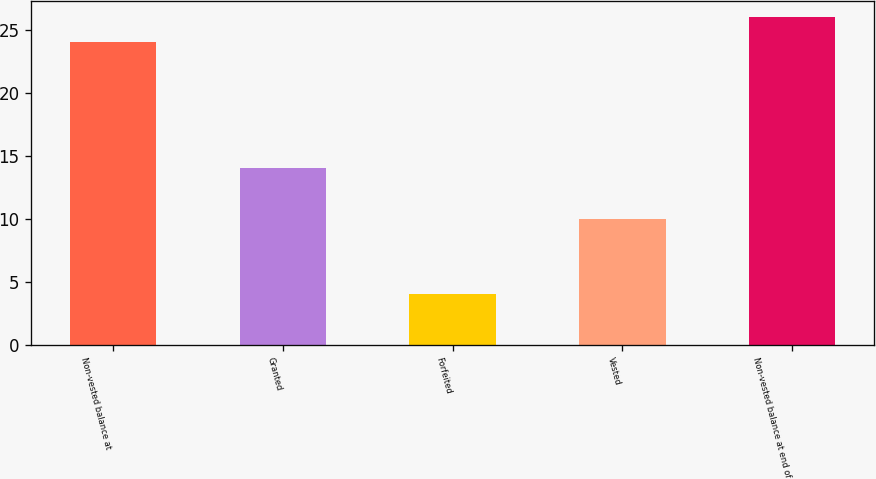Convert chart to OTSL. <chart><loc_0><loc_0><loc_500><loc_500><bar_chart><fcel>Non-vested balance at<fcel>Granted<fcel>Forfeited<fcel>Vested<fcel>Non-vested balance at end of<nl><fcel>24<fcel>14<fcel>4<fcel>10<fcel>26<nl></chart> 